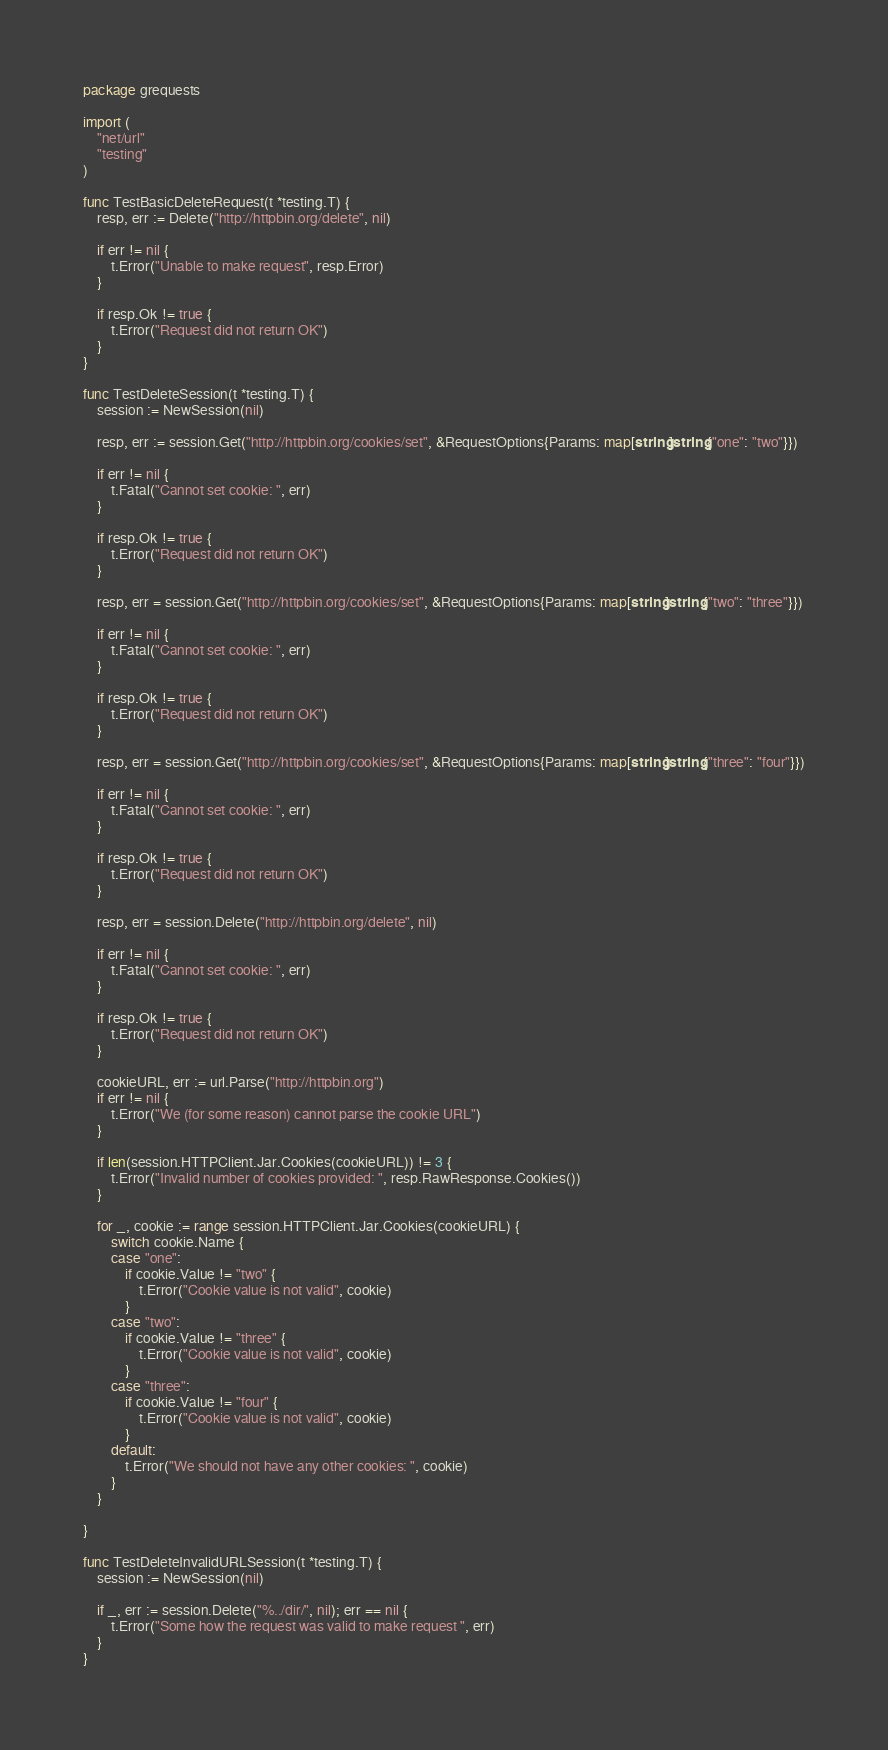<code> <loc_0><loc_0><loc_500><loc_500><_Go_>package grequests

import (
	"net/url"
	"testing"
)

func TestBasicDeleteRequest(t *testing.T) {
	resp, err := Delete("http://httpbin.org/delete", nil)

	if err != nil {
		t.Error("Unable to make request", resp.Error)
	}

	if resp.Ok != true {
		t.Error("Request did not return OK")
	}
}

func TestDeleteSession(t *testing.T) {
	session := NewSession(nil)

	resp, err := session.Get("http://httpbin.org/cookies/set", &RequestOptions{Params: map[string]string{"one": "two"}})

	if err != nil {
		t.Fatal("Cannot set cookie: ", err)
	}

	if resp.Ok != true {
		t.Error("Request did not return OK")
	}

	resp, err = session.Get("http://httpbin.org/cookies/set", &RequestOptions{Params: map[string]string{"two": "three"}})

	if err != nil {
		t.Fatal("Cannot set cookie: ", err)
	}

	if resp.Ok != true {
		t.Error("Request did not return OK")
	}

	resp, err = session.Get("http://httpbin.org/cookies/set", &RequestOptions{Params: map[string]string{"three": "four"}})

	if err != nil {
		t.Fatal("Cannot set cookie: ", err)
	}

	if resp.Ok != true {
		t.Error("Request did not return OK")
	}

	resp, err = session.Delete("http://httpbin.org/delete", nil)

	if err != nil {
		t.Fatal("Cannot set cookie: ", err)
	}

	if resp.Ok != true {
		t.Error("Request did not return OK")
	}

	cookieURL, err := url.Parse("http://httpbin.org")
	if err != nil {
		t.Error("We (for some reason) cannot parse the cookie URL")
	}

	if len(session.HTTPClient.Jar.Cookies(cookieURL)) != 3 {
		t.Error("Invalid number of cookies provided: ", resp.RawResponse.Cookies())
	}

	for _, cookie := range session.HTTPClient.Jar.Cookies(cookieURL) {
		switch cookie.Name {
		case "one":
			if cookie.Value != "two" {
				t.Error("Cookie value is not valid", cookie)
			}
		case "two":
			if cookie.Value != "three" {
				t.Error("Cookie value is not valid", cookie)
			}
		case "three":
			if cookie.Value != "four" {
				t.Error("Cookie value is not valid", cookie)
			}
		default:
			t.Error("We should not have any other cookies: ", cookie)
		}
	}

}

func TestDeleteInvalidURLSession(t *testing.T) {
	session := NewSession(nil)

	if _, err := session.Delete("%../dir/", nil); err == nil {
		t.Error("Some how the request was valid to make request ", err)
	}
}
</code> 